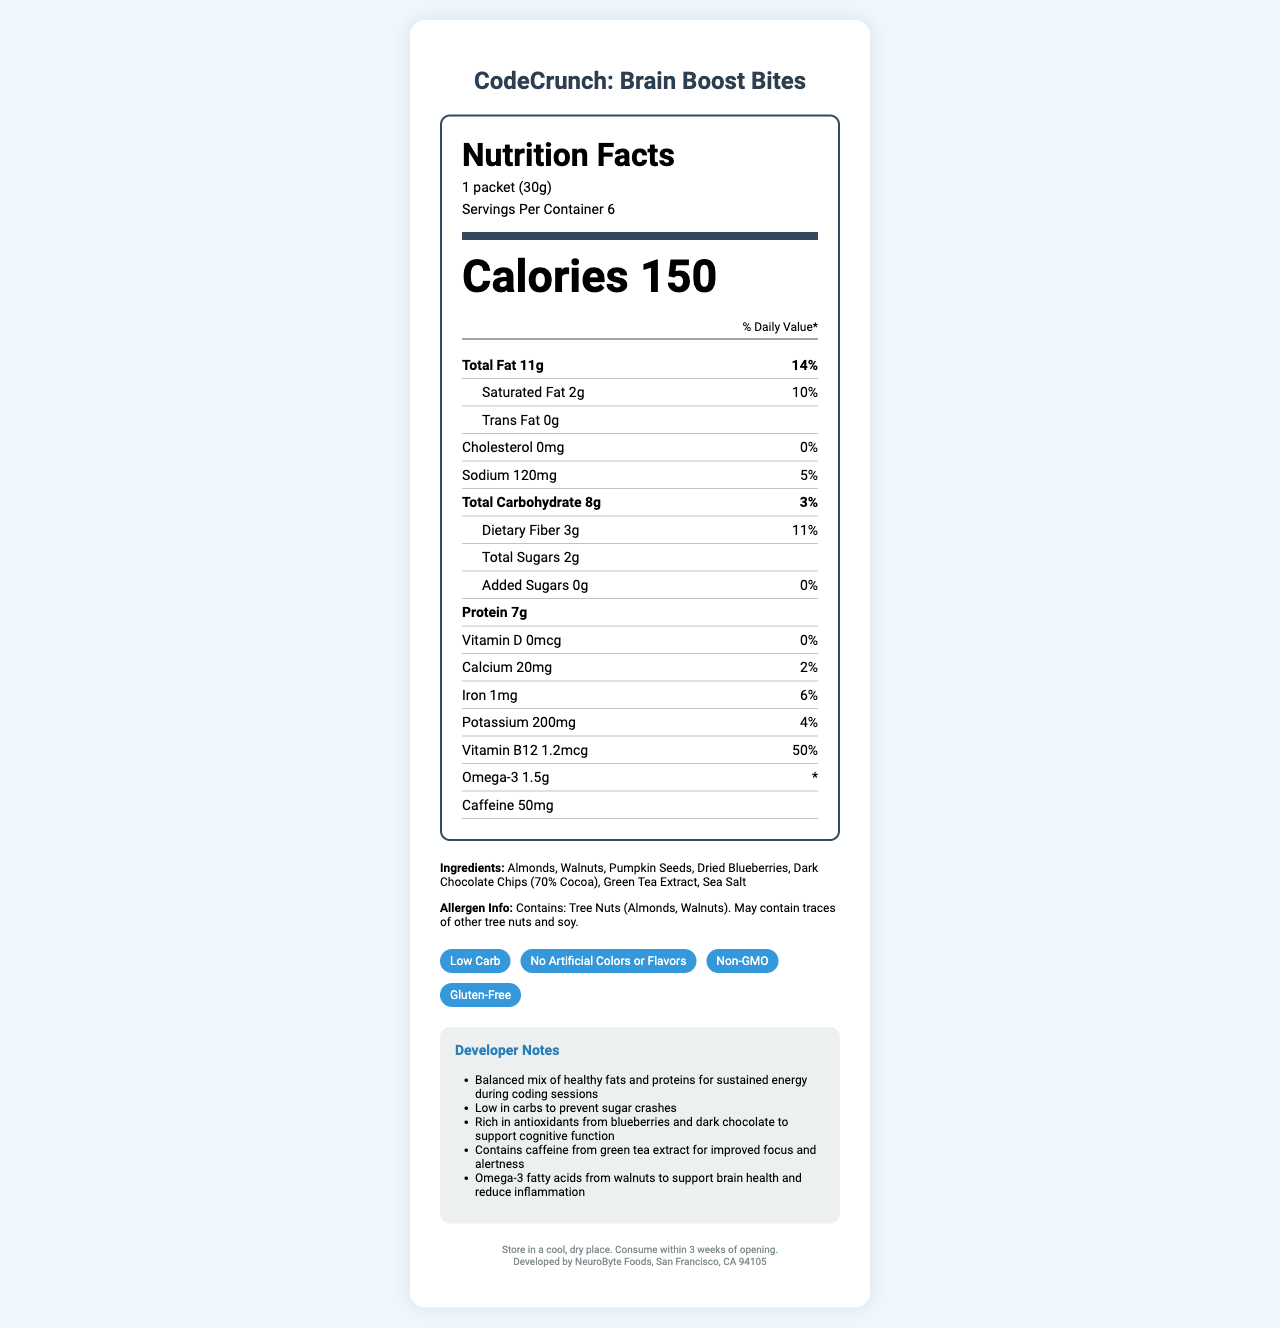what is the serving size for CodeCrunch: Brain Boost Bites? The serving size is mentioned at the top of the nutrition facts section under "Serving Size."
Answer: 1 packet (30g) How many calories are in each serving of the snack? The calorie content per serving is listed prominently in the middle of the nutrition label.
Answer: 150 What is the total amount of fat in one serving? The amount of total fat per serving is provided in the first nutrient listed under "Total Fat" with an amount of 11 grams.
Answer: 11g What percentage of the daily value of saturated fat does one serving provide? The percentage daily value for saturated fat is provided next to the amount (2 grams) under "Saturated Fat."
Answer: 10% How much potassium does one serving contain? The amount of potassium per serving is listed under the nutrients near the end of the label, showing 200 milligrams.
Answer: 200mg Which of the following is NOT an ingredient in CodeCrunch: Brain Boost Bites? A. Almonds B. Dried Blueberries C. Soy Lecithin D. Pumpkin Seeds Soy Lecithin is not listed under the ingredients, while the other options are.
Answer: C What is the main source of caffeine in this snack? A. Coffee Extract B. Green Tea Extract C. Cocoa D. Guarana The document states that Green Tea Extract is one of the ingredients, which is the source of caffeine.
Answer: B Is there any cholesterol in CodeCrunch: Brain Boost Bites? The nutrition label specifies that the Cholesterol amount is 0mg.
Answer: No Do the bites contain any added sugars? The amount of added sugars is listed as 0g, meaning there are no added sugars.
Answer: No Briefly summarize the main idea of the document. The summary encompasses the product's purpose, nutritional content, ingredients, health benefits, and storage instructions as detailed in the document.
Answer: CodeCrunch: Brain Boost Bites is a low-carb snack designed to boost brain function and sustain energy for software engineers. Each serving has 150 calories, with a balanced mix of fats, proteins, and low carbs to avoid sugar crashes. It includes ingredients such as almonds, walnuts, and green tea extract, providing antioxidants, omega-3 fats, and caffeine for alertness. The product is allergen-aware, claiming to be non-GMO and gluten-free, and should be stored in cool, dry conditions. How should the bites be stored? The storage instructions are found in the footer of the document.
Answer: In a cool, dry place, and consumed within 3 weeks of opening What is the main benefit of including omega-3 fatty acids in the snack? One of the developer notes mentions the benefits of omega-3 fatty acids, which are sourced from walnuts in the snack.
Answer: Support brain health and reduce inflammation What is the branding or manufacturing company for CodeCrunch: Brain Boost Bites? The manufacturer information is found in the footer of the document.
Answer: NeuroByte Foods Does the product make any claims about artificial colors or flavors? One of the claims listed is "No Artificial Colors or Flavors."
Answer: Yes How much dietary fiber is in a single serving? The amount of dietary fiber per serving is listed under "Dietary Fiber" within the Total Carbohydrate section, showing 3 grams.
Answer: 3g Could you tell what coding language was used to generate this document? Information about the coding language used to generate the document is not visually available in the provided document.
Answer: Cannot be determined 